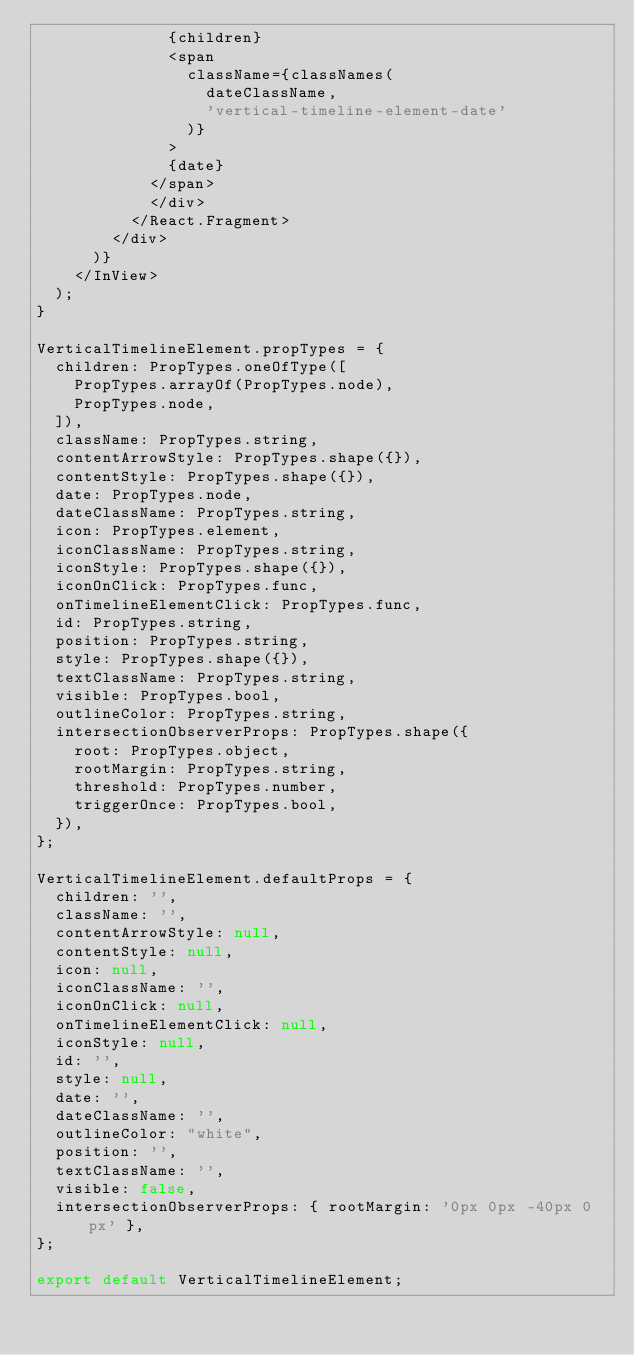Convert code to text. <code><loc_0><loc_0><loc_500><loc_500><_JavaScript_>              {children}
              <span
                className={classNames(
                  dateClassName,
                  'vertical-timeline-element-date'
                )}
              >
              {date}
            </span>
            </div>
          </React.Fragment>
        </div>
      )}
    </InView>
  );
}

VerticalTimelineElement.propTypes = {
  children: PropTypes.oneOfType([
    PropTypes.arrayOf(PropTypes.node),
    PropTypes.node,
  ]),
  className: PropTypes.string,
  contentArrowStyle: PropTypes.shape({}),
  contentStyle: PropTypes.shape({}),
  date: PropTypes.node,
  dateClassName: PropTypes.string,
  icon: PropTypes.element,
  iconClassName: PropTypes.string,
  iconStyle: PropTypes.shape({}),
  iconOnClick: PropTypes.func,
  onTimelineElementClick: PropTypes.func,
  id: PropTypes.string,
  position: PropTypes.string,
  style: PropTypes.shape({}),
  textClassName: PropTypes.string,
  visible: PropTypes.bool,
  outlineColor: PropTypes.string,
  intersectionObserverProps: PropTypes.shape({
    root: PropTypes.object,
    rootMargin: PropTypes.string,
    threshold: PropTypes.number,
    triggerOnce: PropTypes.bool,
  }),
};

VerticalTimelineElement.defaultProps = {
  children: '',
  className: '',
  contentArrowStyle: null,
  contentStyle: null,
  icon: null,
  iconClassName: '',
  iconOnClick: null,
  onTimelineElementClick: null,
  iconStyle: null,
  id: '',
  style: null,
  date: '',
  dateClassName: '',
  outlineColor: "white",
  position: '',
  textClassName: '',
  visible: false,
  intersectionObserverProps: { rootMargin: '0px 0px -40px 0px' },
};

export default VerticalTimelineElement;
</code> 